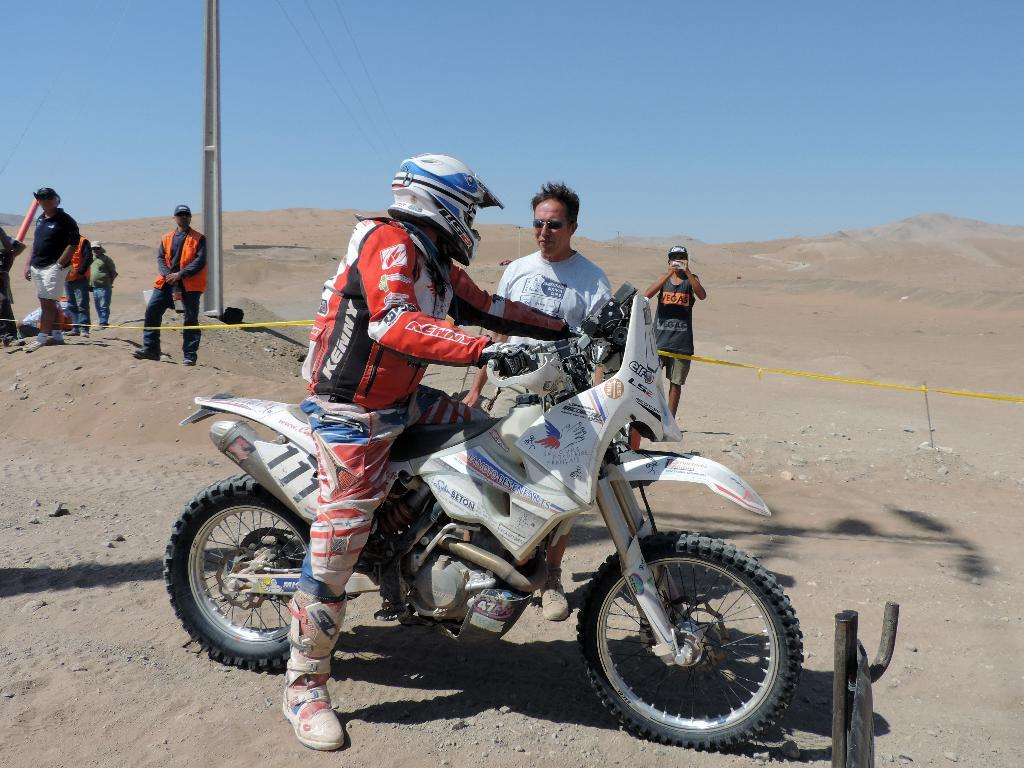Who or what can be seen in the image? There are people in the image. What vehicle is present in the image? There is a motorcycle in the image. What part of the natural environment is visible in the image? The sky is visible in the image. Where is the donkey nesting in the image? There is no donkey or nest present in the image. 